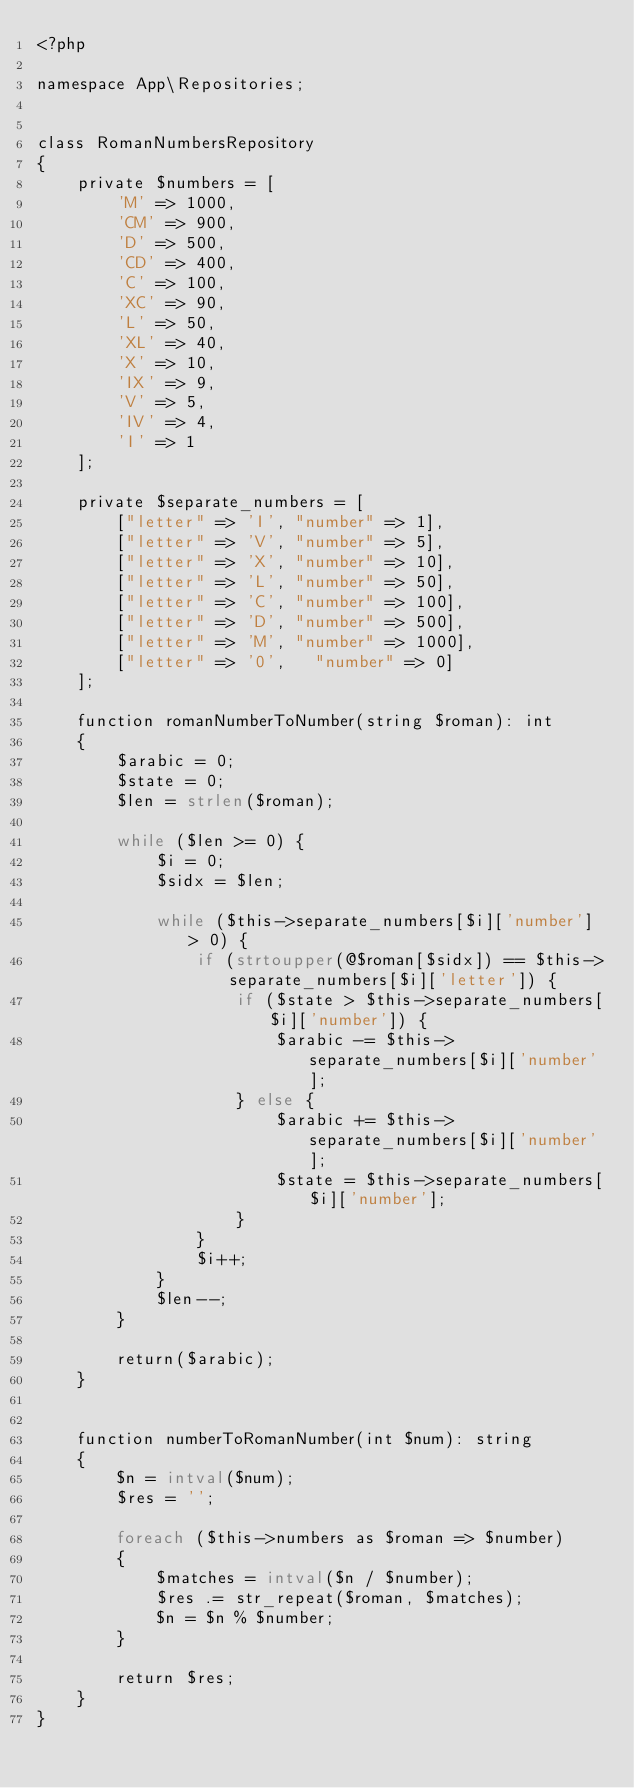<code> <loc_0><loc_0><loc_500><loc_500><_PHP_><?php

namespace App\Repositories;


class RomanNumbersRepository
{
    private $numbers = [
        'M' => 1000,
        'CM' => 900,
        'D' => 500,
        'CD' => 400,
        'C' => 100,
        'XC' => 90,
        'L' => 50,
        'XL' => 40,
        'X' => 10,
        'IX' => 9,
        'V' => 5,
        'IV' => 4,
        'I' => 1
    ];

    private $separate_numbers = [
        ["letter" => 'I', "number" => 1],
        ["letter" => 'V', "number" => 5],
        ["letter" => 'X', "number" => 10],
        ["letter" => 'L', "number" => 50],
        ["letter" => 'C', "number" => 100],
        ["letter" => 'D', "number" => 500],
        ["letter" => 'M', "number" => 1000],
        ["letter" => '0',   "number" => 0]
    ];

    function romanNumberToNumber(string $roman): int
    {
        $arabic = 0;
        $state = 0;
        $len = strlen($roman);

        while ($len >= 0) {
            $i = 0;
            $sidx = $len;

            while ($this->separate_numbers[$i]['number'] > 0) {
                if (strtoupper(@$roman[$sidx]) == $this->separate_numbers[$i]['letter']) {
                    if ($state > $this->separate_numbers[$i]['number']) {
                        $arabic -= $this->separate_numbers[$i]['number'];
                    } else {
                        $arabic += $this->separate_numbers[$i]['number'];
                        $state = $this->separate_numbers[$i]['number'];
                    }
                }
                $i++;
            }
            $len--;
        }

        return($arabic);
    }


    function numberToRomanNumber(int $num): string
    {
        $n = intval($num);
        $res = '';

        foreach ($this->numbers as $roman => $number)
        {
            $matches = intval($n / $number);
            $res .= str_repeat($roman, $matches);
            $n = $n % $number;
        }

        return $res;
    }
}
</code> 